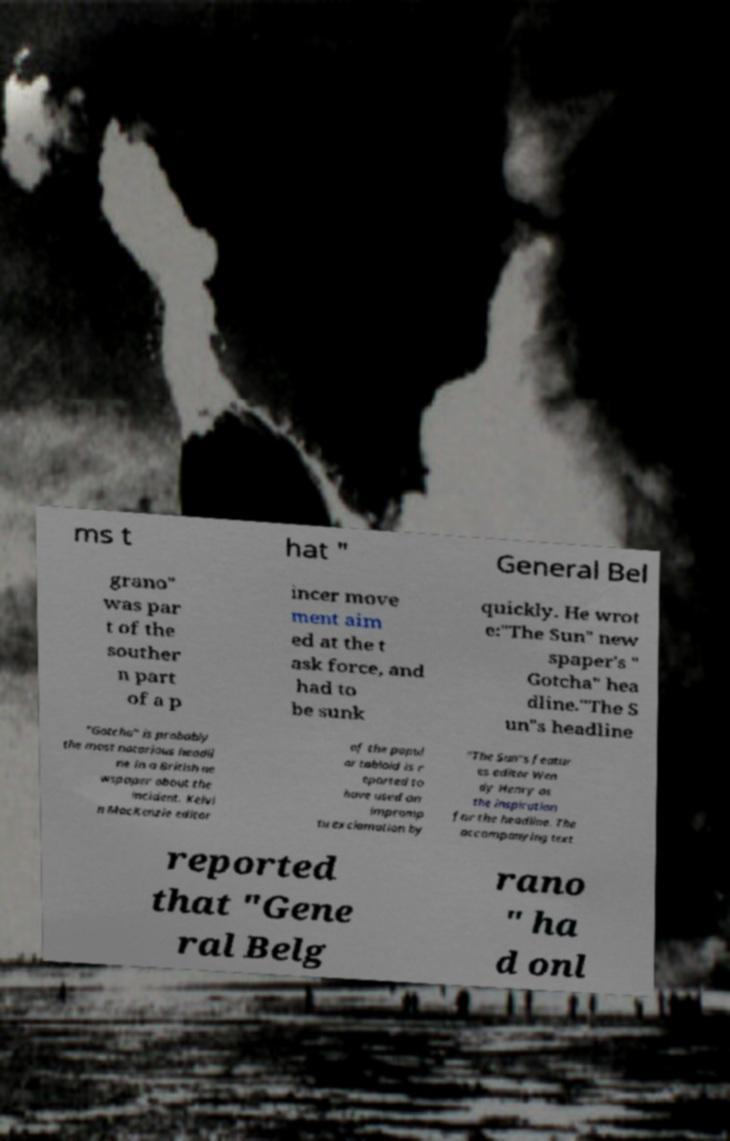I need the written content from this picture converted into text. Can you do that? ms t hat " General Bel grano" was par t of the souther n part of a p incer move ment aim ed at the t ask force, and had to be sunk quickly. He wrot e:"The Sun" new spaper's " Gotcha" hea dline."The S un"s headline "Gotcha" is probably the most notorious headli ne in a British ne wspaper about the incident. Kelvi n MacKenzie editor of the popul ar tabloid is r eported to have used an impromp tu exclamation by "The Sun"s featur es editor Wen dy Henry as the inspiration for the headline. The accompanying text reported that "Gene ral Belg rano " ha d onl 